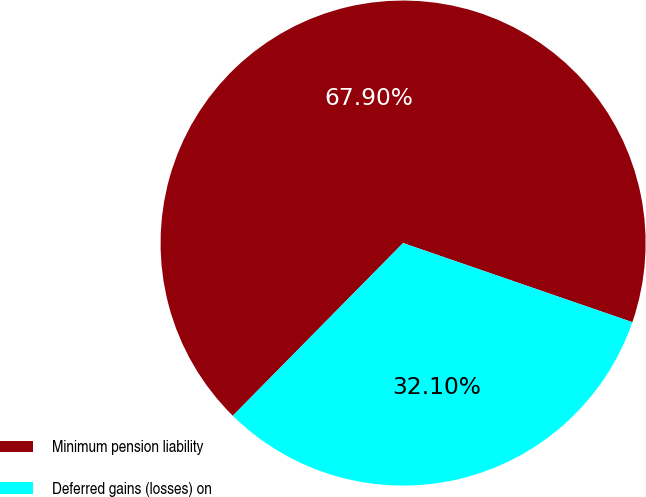<chart> <loc_0><loc_0><loc_500><loc_500><pie_chart><fcel>Minimum pension liability<fcel>Deferred gains (losses) on<nl><fcel>67.9%<fcel>32.1%<nl></chart> 